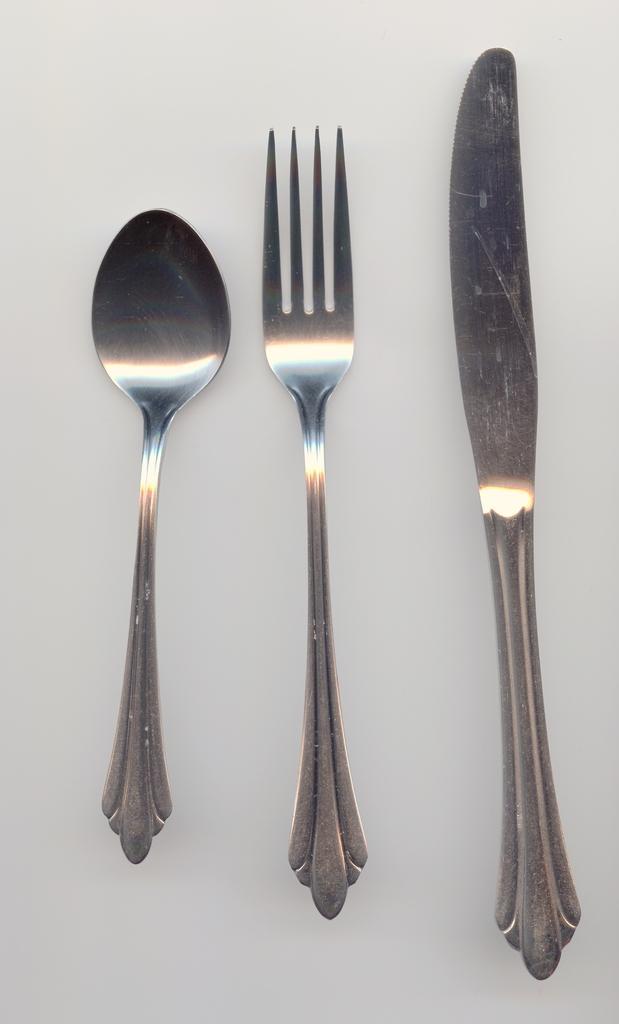Describe this image in one or two sentences. In this picture I can see there is a spoon, fork and a knife placed on the white surface. 